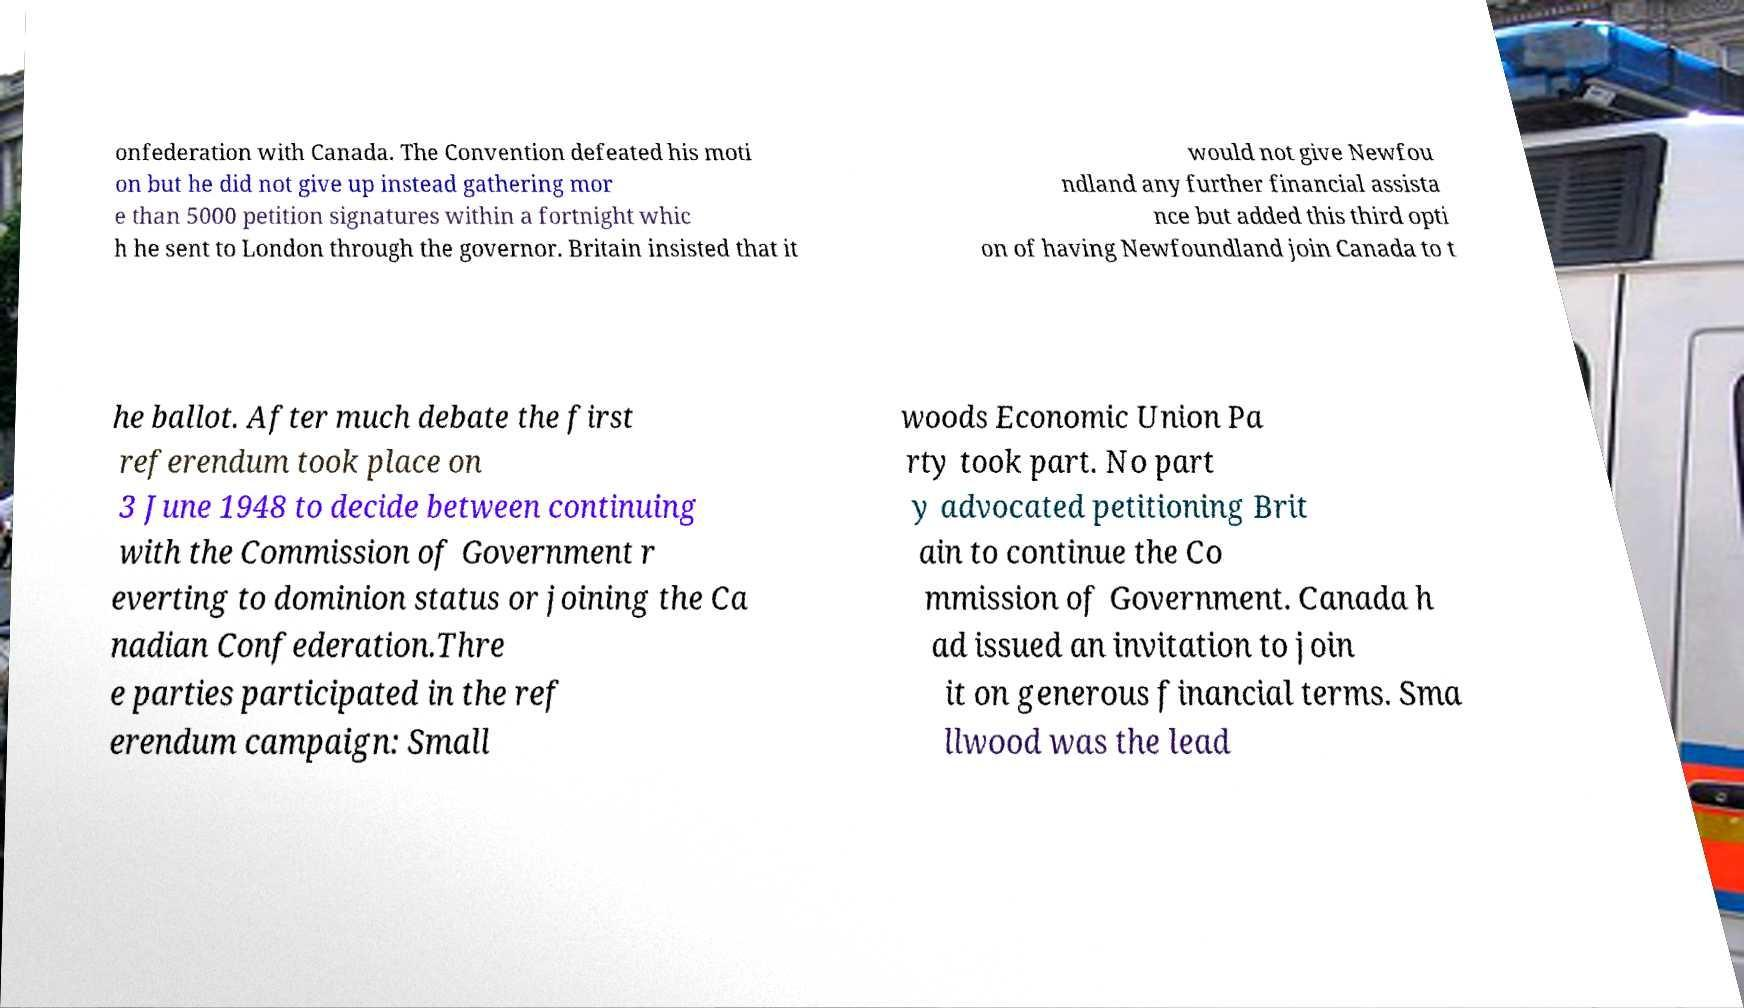What messages or text are displayed in this image? I need them in a readable, typed format. onfederation with Canada. The Convention defeated his moti on but he did not give up instead gathering mor e than 5000 petition signatures within a fortnight whic h he sent to London through the governor. Britain insisted that it would not give Newfou ndland any further financial assista nce but added this third opti on of having Newfoundland join Canada to t he ballot. After much debate the first referendum took place on 3 June 1948 to decide between continuing with the Commission of Government r everting to dominion status or joining the Ca nadian Confederation.Thre e parties participated in the ref erendum campaign: Small woods Economic Union Pa rty took part. No part y advocated petitioning Brit ain to continue the Co mmission of Government. Canada h ad issued an invitation to join it on generous financial terms. Sma llwood was the lead 